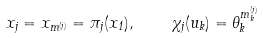<formula> <loc_0><loc_0><loc_500><loc_500>x _ { j } = x _ { { m } ^ { ( j ) } } = \pi _ { j } ( x _ { 1 } ) , \quad \chi _ { j } ( u _ { k } ) = \theta _ { k } ^ { m ^ { ( j ) } _ { k } }</formula> 